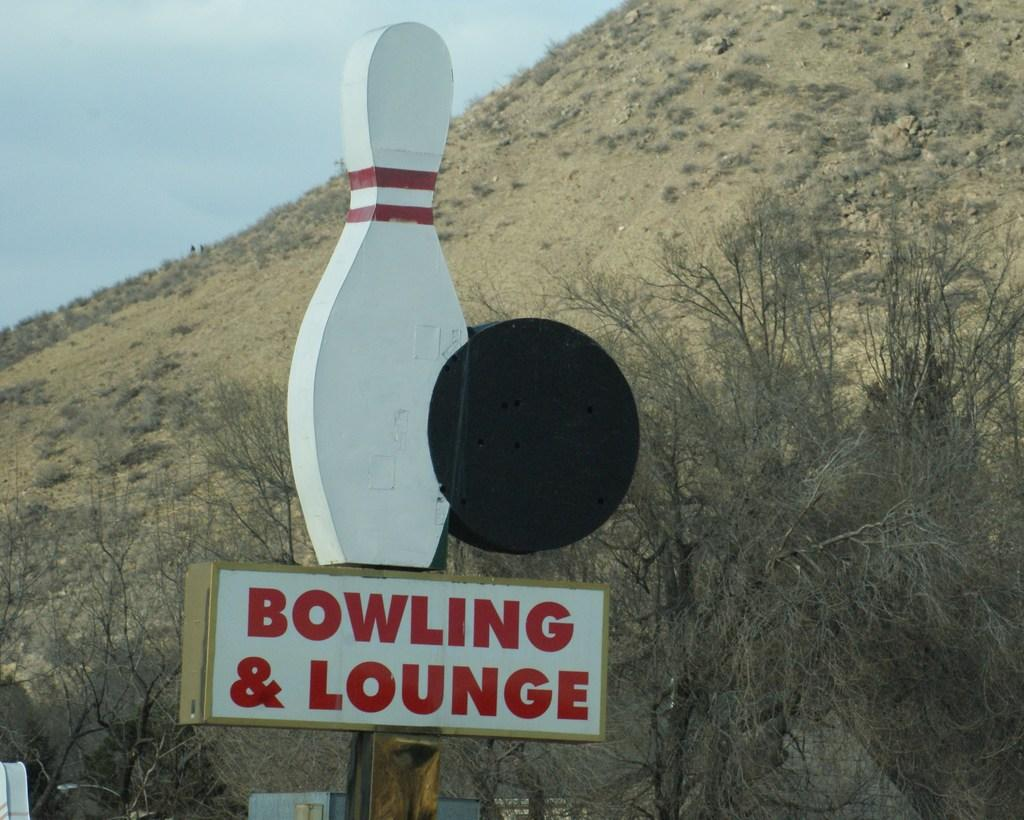What is the main subject of the image? The main subject of the image is a bowling board. What else can be seen in the image besides the bowling board? There is a lounge with a pole in the image. What is visible in the background of the image? Trees, a hill, and the sky are visible in the background of the image. What type of calculator is being used in the image? There is no calculator present in the image. What unit of measurement is being used to determine the height of the hill in the image? The image does not provide any information about the unit of measurement used to determine the height of the hill. 